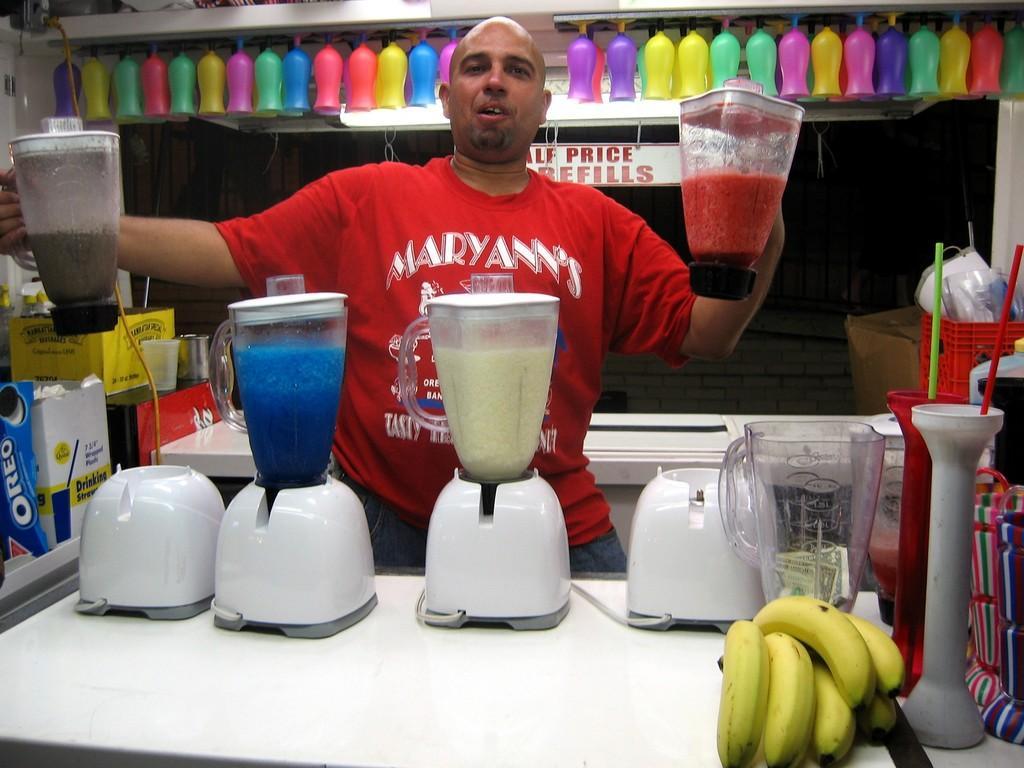Could you give a brief overview of what you see in this image? Here in this picture in the front we can see a table, on which we can see number of mixers present over there and we can also see number of jars on it with juices in them, we can also see bananas and straws and all other things present on the table over there and behind that we can see a person standing and he is holding two jars in his hands and behind him also we can see a table and above that in the racks we can see bottles present over there and on the left side we can see boxes of something is present on the table over there. 